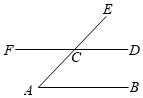As shown in the diagram, AB is parallel to CD. AE intersects DF at point C, and angle ECF is equal to 134°. The degree measure of angle A is ()
Choices:
A: 54°
B: 46°
C: 45°
D: 44° To solve for the measure of angle A, observe that AB is parallel to CD, and AE is a transversal that intersects these lines at points B and D respectively. This setup implies the angle A and angle ECD are corresponding angles; therefore, they are equal. 

Given that angle ECF is 134°, and knowing the sum of angles on a straight line is 180°, angle ECD can be calculated as:
180° - 134° = 46°.

Therefore, angle A, being equal to angle ECD, measures 46°. 

Answer: B. 